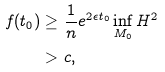Convert formula to latex. <formula><loc_0><loc_0><loc_500><loc_500>f ( t _ { 0 } ) \geq & \ \frac { 1 } { n } e ^ { 2 \epsilon t _ { 0 } } \inf _ { M _ { 0 } } H ^ { 2 } \\ > & \ c ,</formula> 